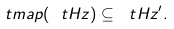<formula> <loc_0><loc_0><loc_500><loc_500>\ t m a p ( \ t H z ) \subseteq \ t H z ^ { \prime } .</formula> 